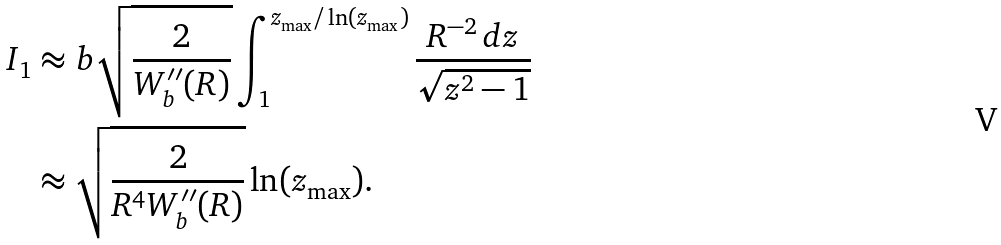<formula> <loc_0><loc_0><loc_500><loc_500>I _ { 1 } & \approx b \sqrt { \frac { 2 } { W _ { b } ^ { \prime \prime } ( R ) } } \int _ { 1 } ^ { z _ { \max } / \ln ( z _ { \max } ) } \frac { R ^ { - 2 } \, d z } { \sqrt { z ^ { 2 } - 1 } } \\ & \approx \sqrt { \frac { 2 } { R ^ { 4 } W _ { b } ^ { \prime \prime } ( R ) } } \ln ( z _ { \max } ) .</formula> 